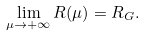Convert formula to latex. <formula><loc_0><loc_0><loc_500><loc_500>\lim _ { \mu \rightarrow + \infty } R ( \mu ) = R _ { G } .</formula> 